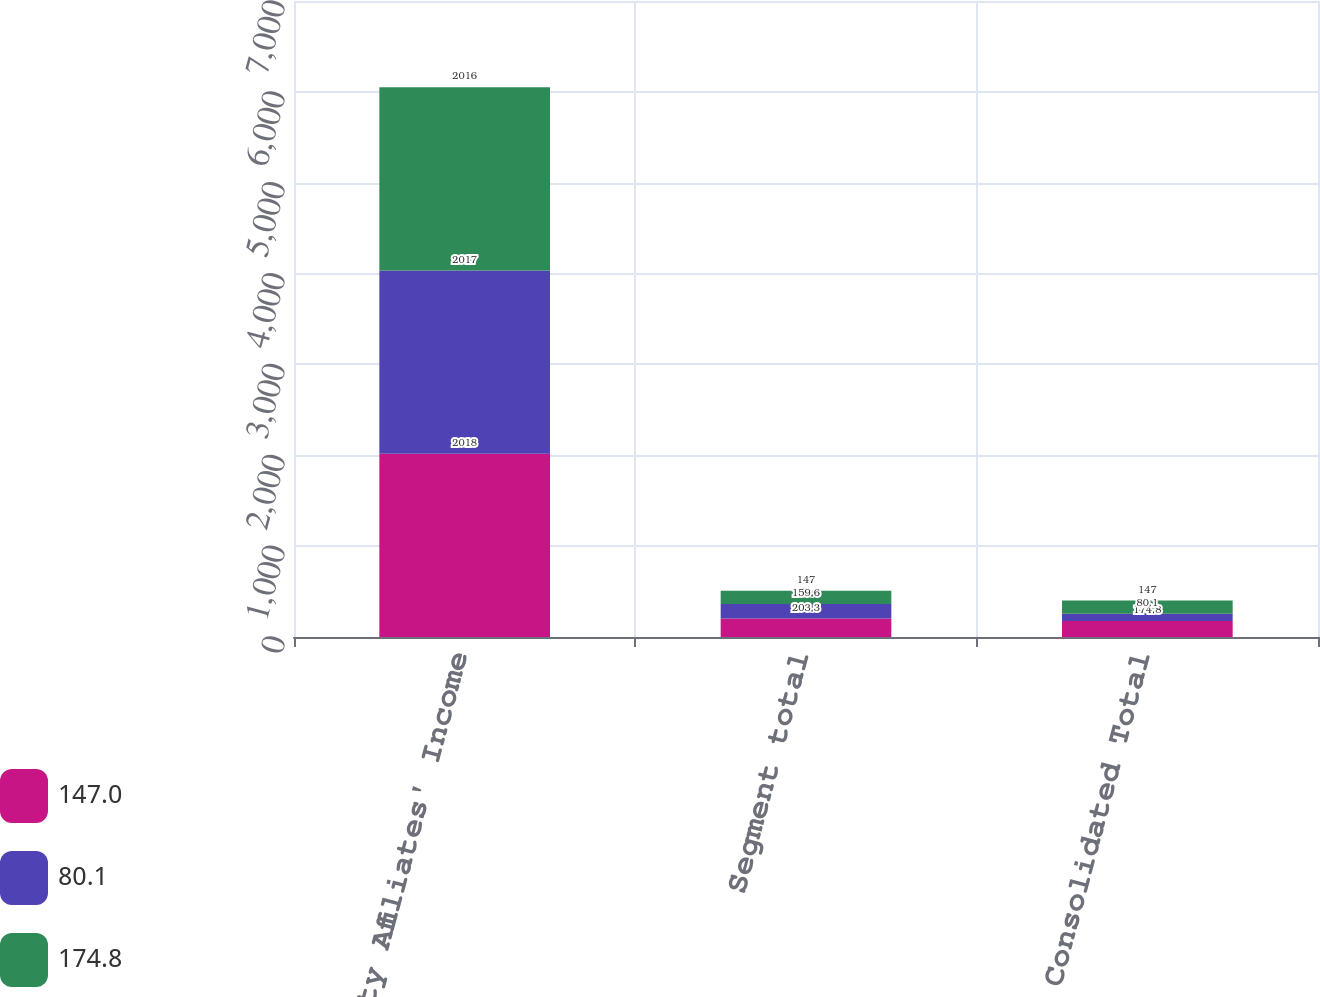<chart> <loc_0><loc_0><loc_500><loc_500><stacked_bar_chart><ecel><fcel>Equity Affiliates' Income<fcel>Segment total<fcel>Consolidated Total<nl><fcel>147<fcel>2018<fcel>203.3<fcel>174.8<nl><fcel>80.1<fcel>2017<fcel>159.6<fcel>80.1<nl><fcel>174.8<fcel>2016<fcel>147<fcel>147<nl></chart> 